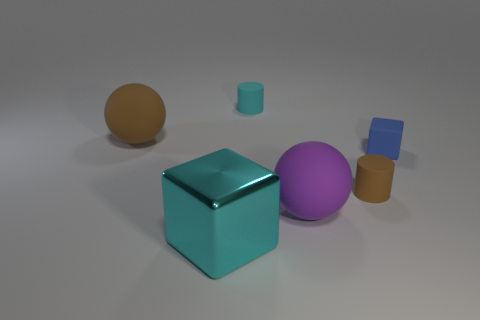Are there any brown cylinders that have the same size as the matte block?
Ensure brevity in your answer.  Yes. Is the number of big cyan metal cubes in front of the purple ball less than the number of cyan shiny objects?
Make the answer very short. No. The ball that is right of the large thing on the left side of the large shiny block to the left of the big purple matte sphere is made of what material?
Your answer should be compact. Rubber. Are there more small cyan matte cylinders that are behind the small cyan rubber cylinder than small cyan objects in front of the big brown sphere?
Ensure brevity in your answer.  No. What number of matte things are red blocks or small blocks?
Make the answer very short. 1. There is a small thing that is the same color as the big metallic thing; what shape is it?
Offer a very short reply. Cylinder. What material is the large ball in front of the small matte block?
Give a very brief answer. Rubber. What number of objects are tiny cyan rubber objects or cyan cylinders behind the large cyan thing?
Give a very brief answer. 1. What is the shape of the blue thing that is the same size as the cyan rubber cylinder?
Give a very brief answer. Cube. What number of rubber blocks have the same color as the large metal thing?
Your answer should be compact. 0. 